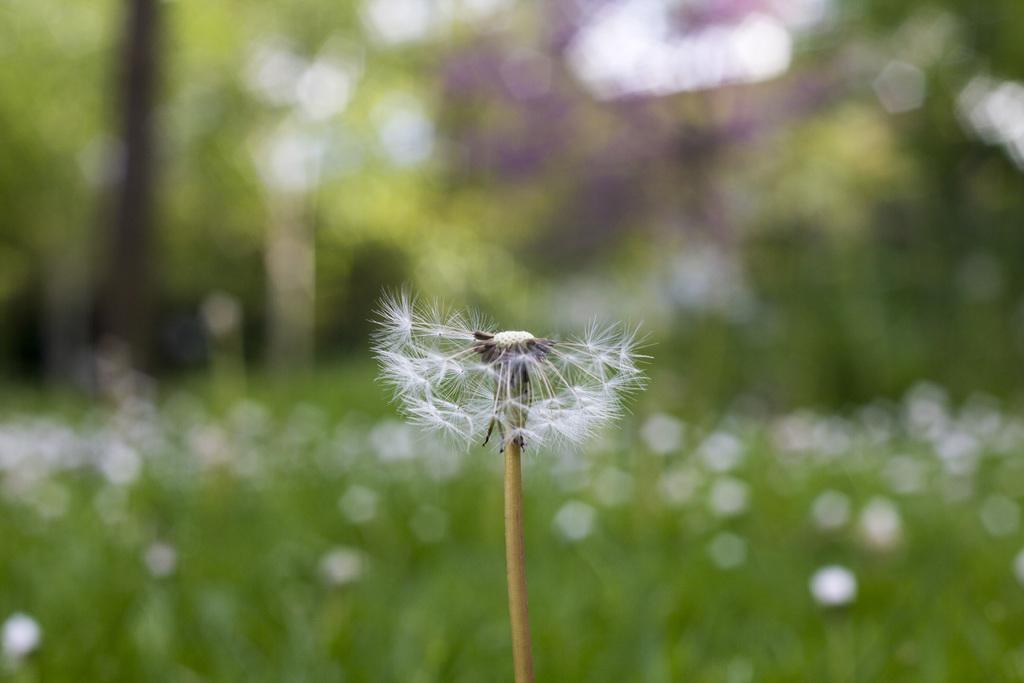Could you give a brief overview of what you see in this image? As we can see in the image, there is a dandelion plant in the front and the background is blurry. 